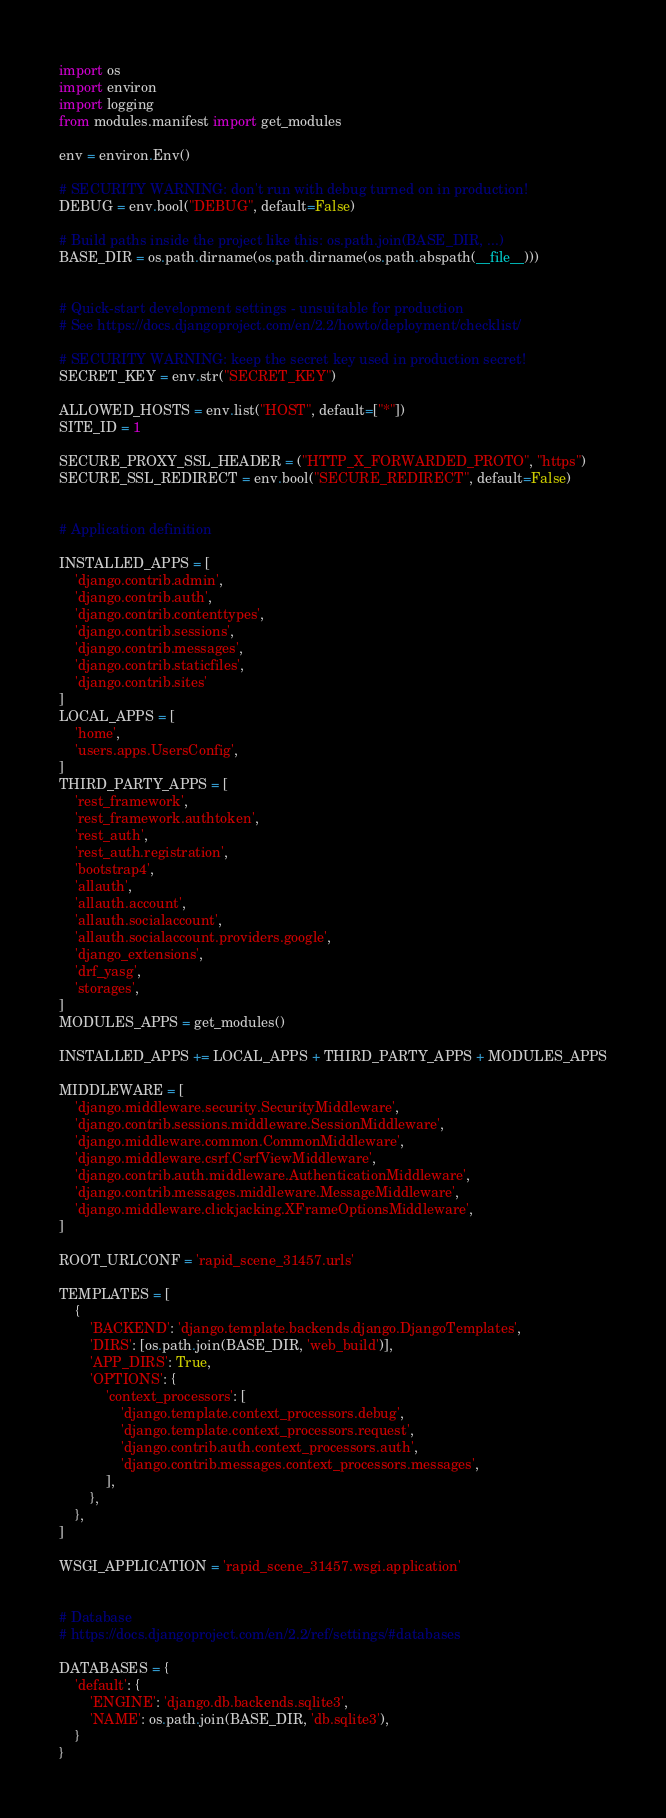<code> <loc_0><loc_0><loc_500><loc_500><_Python_>import os
import environ
import logging
from modules.manifest import get_modules

env = environ.Env()

# SECURITY WARNING: don't run with debug turned on in production!
DEBUG = env.bool("DEBUG", default=False)

# Build paths inside the project like this: os.path.join(BASE_DIR, ...)
BASE_DIR = os.path.dirname(os.path.dirname(os.path.abspath(__file__)))


# Quick-start development settings - unsuitable for production
# See https://docs.djangoproject.com/en/2.2/howto/deployment/checklist/

# SECURITY WARNING: keep the secret key used in production secret!
SECRET_KEY = env.str("SECRET_KEY")

ALLOWED_HOSTS = env.list("HOST", default=["*"])
SITE_ID = 1

SECURE_PROXY_SSL_HEADER = ("HTTP_X_FORWARDED_PROTO", "https")
SECURE_SSL_REDIRECT = env.bool("SECURE_REDIRECT", default=False)


# Application definition

INSTALLED_APPS = [
    'django.contrib.admin',
    'django.contrib.auth',
    'django.contrib.contenttypes',
    'django.contrib.sessions',
    'django.contrib.messages',
    'django.contrib.staticfiles',
    'django.contrib.sites'
]
LOCAL_APPS = [
    'home',
    'users.apps.UsersConfig',
]
THIRD_PARTY_APPS = [
    'rest_framework',
    'rest_framework.authtoken',
    'rest_auth',
    'rest_auth.registration',
    'bootstrap4',
    'allauth',
    'allauth.account',
    'allauth.socialaccount',
    'allauth.socialaccount.providers.google',
    'django_extensions',
    'drf_yasg',
    'storages',
]
MODULES_APPS = get_modules()

INSTALLED_APPS += LOCAL_APPS + THIRD_PARTY_APPS + MODULES_APPS

MIDDLEWARE = [
    'django.middleware.security.SecurityMiddleware',
    'django.contrib.sessions.middleware.SessionMiddleware',
    'django.middleware.common.CommonMiddleware',
    'django.middleware.csrf.CsrfViewMiddleware',
    'django.contrib.auth.middleware.AuthenticationMiddleware',
    'django.contrib.messages.middleware.MessageMiddleware',
    'django.middleware.clickjacking.XFrameOptionsMiddleware',
]

ROOT_URLCONF = 'rapid_scene_31457.urls'

TEMPLATES = [
    {
        'BACKEND': 'django.template.backends.django.DjangoTemplates',
        'DIRS': [os.path.join(BASE_DIR, 'web_build')],
        'APP_DIRS': True,
        'OPTIONS': {
            'context_processors': [
                'django.template.context_processors.debug',
                'django.template.context_processors.request',
                'django.contrib.auth.context_processors.auth',
                'django.contrib.messages.context_processors.messages',
            ],
        },
    },
]

WSGI_APPLICATION = 'rapid_scene_31457.wsgi.application'


# Database
# https://docs.djangoproject.com/en/2.2/ref/settings/#databases

DATABASES = {
    'default': {
        'ENGINE': 'django.db.backends.sqlite3',
        'NAME': os.path.join(BASE_DIR, 'db.sqlite3'),
    }
}
</code> 